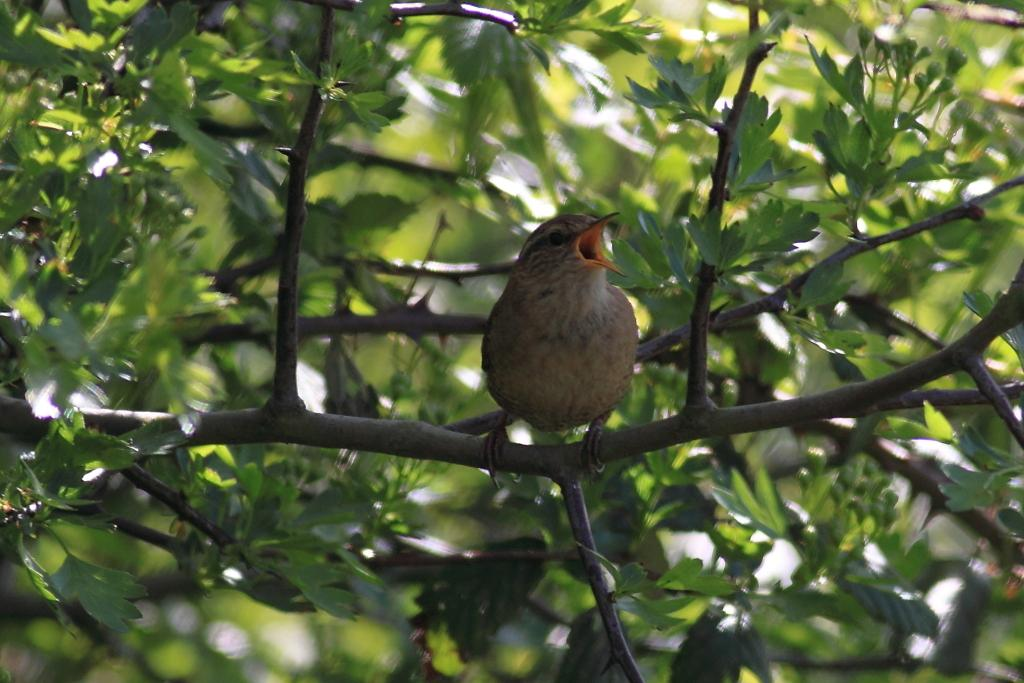What type of animal can be seen in the image? There is a bird in the image. Where is the bird located in the image? The bird is sitting on a stem. What can be seen in the background of the image? There are plants and leaves present in the background of the image. How many horses can be seen in the image? There are no horses present in the image; it features a bird sitting on a stem. What type of footwear is the bird wearing in the image? Birds do not wear footwear, and there is no indication of any in the image. 